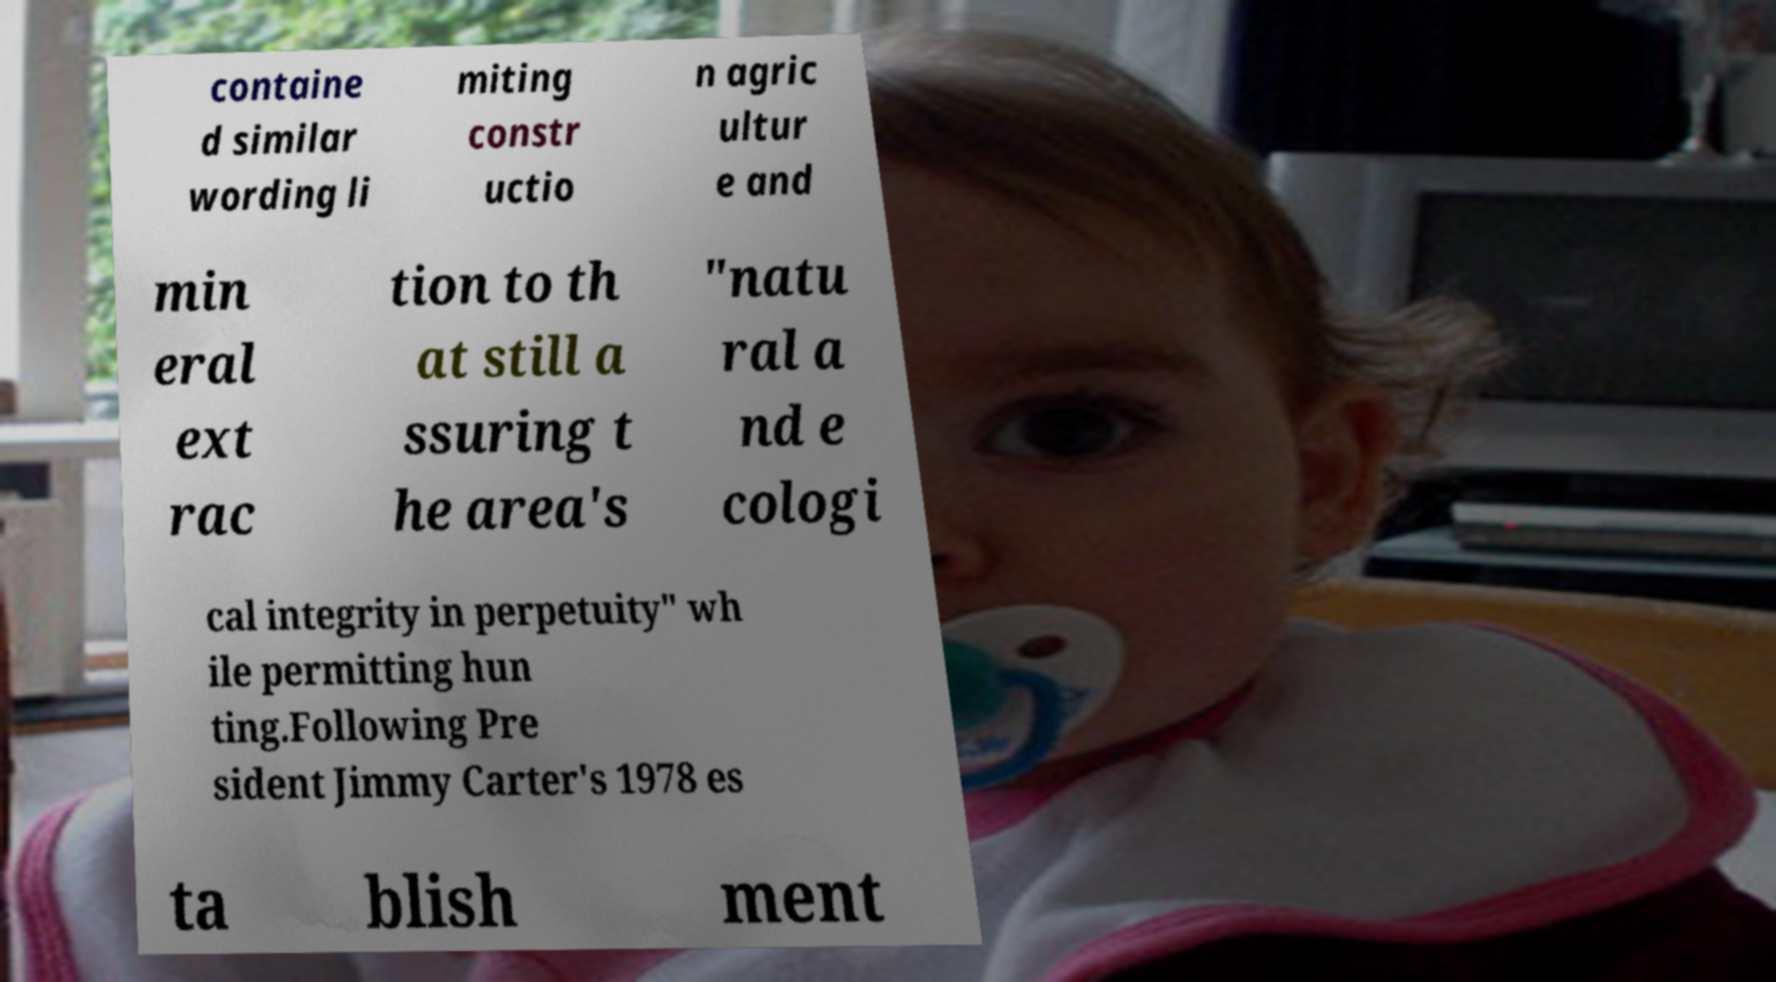For documentation purposes, I need the text within this image transcribed. Could you provide that? containe d similar wording li miting constr uctio n agric ultur e and min eral ext rac tion to th at still a ssuring t he area's "natu ral a nd e cologi cal integrity in perpetuity" wh ile permitting hun ting.Following Pre sident Jimmy Carter's 1978 es ta blish ment 